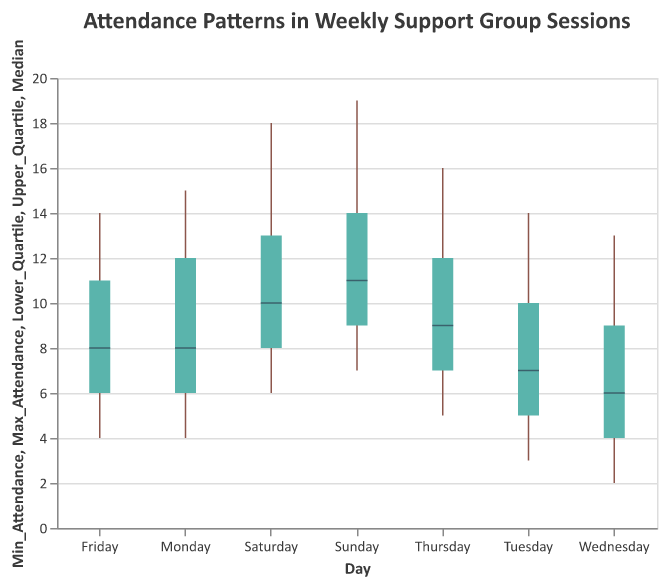What is the title of the figure? The title of a figure provides a summary of the information presented. The title is located at the top of the chart.
Answer: Attendance Patterns in Weekly Support Group Sessions Which day has the highest maximum attendance? To find the highest maximum attendance, look at the top values of the candlesticks for each day of the week and determine which is the highest.
Answer: Sunday What is the median attendance on Thursday? Identify the position of Thursday. The median attendance value is shown by the tick mark inside the box.
Answer: 9 Which day has the lowest minimum attendance? Compare the bottom values of the candlesticks for each day to find the smallest one.
Answer: Wednesday What is the interquartile range (IQR) of attendance on Tuesday? The interquartile range is the difference between the upper and lower quartiles. For Tuesday, subtract the lower quartile from the upper quartile (10 - 5).
Answer: 5 On which day is the median attendance highest? Examine the position of the tick marks within the boxes for each day to see which is the highest.
Answer: Sunday How does the range of attendance on Saturday compare to that on Wednesday? The range is the difference between the maximum and minimum values. For Saturday, it is 18 - 6 = 12; for Wednesday, it is 13 - 2 = 11. Saturday's range is slightly larger.
Answer: Saturday's range is larger by 1 Which day has the smallest interquartile range (IQR)? The interquartile range is the difference between the upper and lower quartiles. Calculate this for each day and compare.
Answer: Wednesday What is the average median attendance for the entire week? Add the median attendance values for all days and divide by the number of days: (8 + 7 + 6 + 9 + 8 + 10 + 11) / 7.
Answer: Approximately 8.43 What is the difference between maximum and minimum attendances on Monday? Subtract the minimum attendance from the maximum attendance for Monday (15 - 4).
Answer: 11 